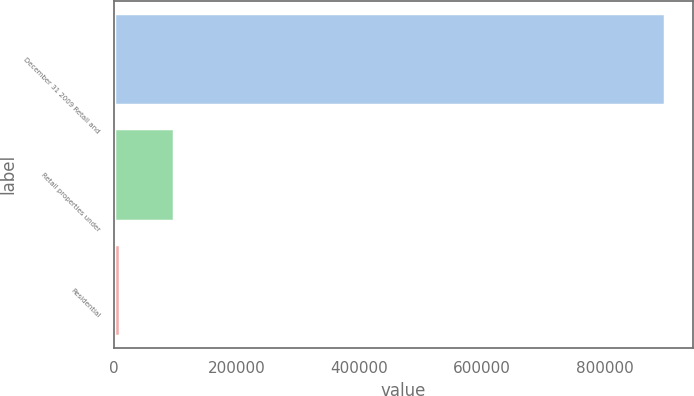<chart> <loc_0><loc_0><loc_500><loc_500><bar_chart><fcel>December 31 2009 Retail and<fcel>Retail properties under<fcel>Residential<nl><fcel>899120<fcel>98647.4<fcel>9706<nl></chart> 